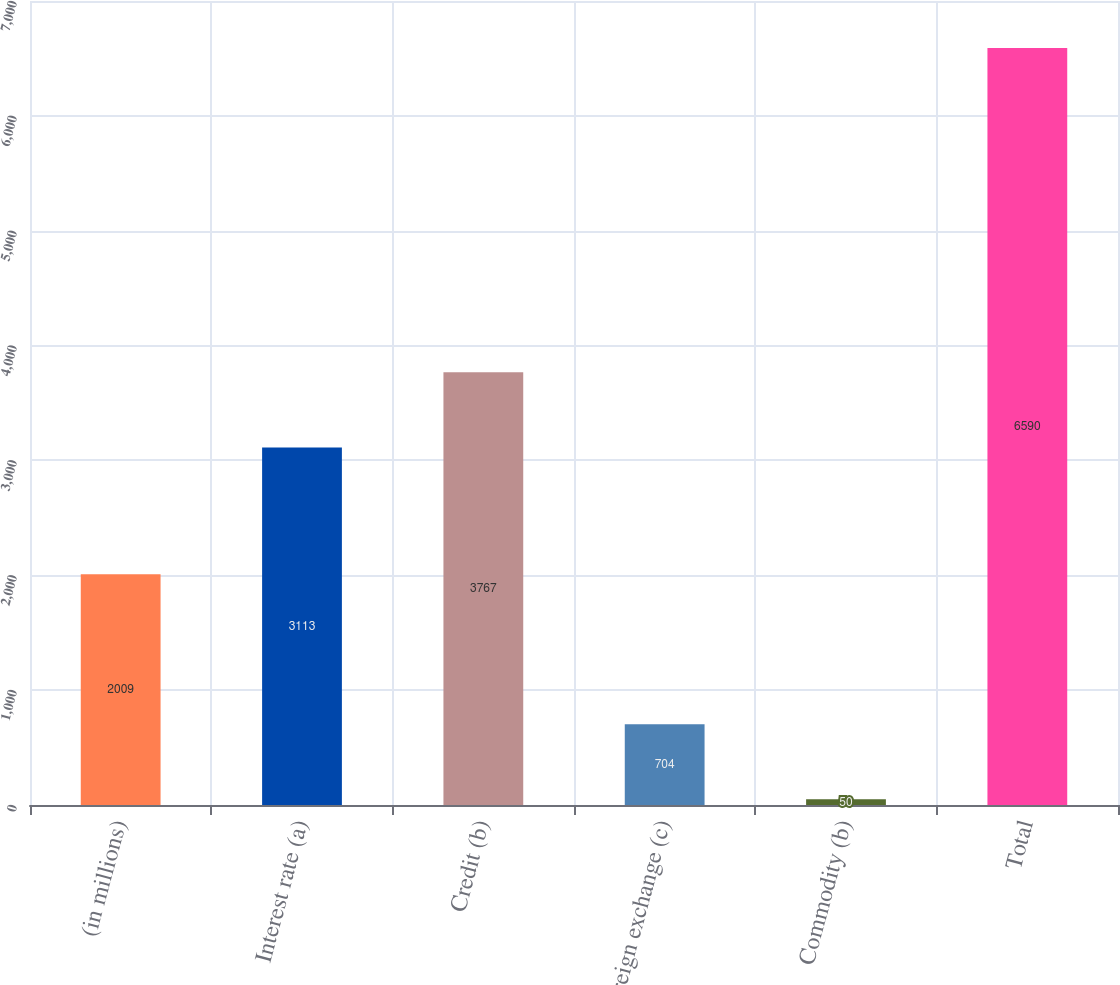Convert chart to OTSL. <chart><loc_0><loc_0><loc_500><loc_500><bar_chart><fcel>(in millions)<fcel>Interest rate (a)<fcel>Credit (b)<fcel>Foreign exchange (c)<fcel>Commodity (b)<fcel>Total<nl><fcel>2009<fcel>3113<fcel>3767<fcel>704<fcel>50<fcel>6590<nl></chart> 